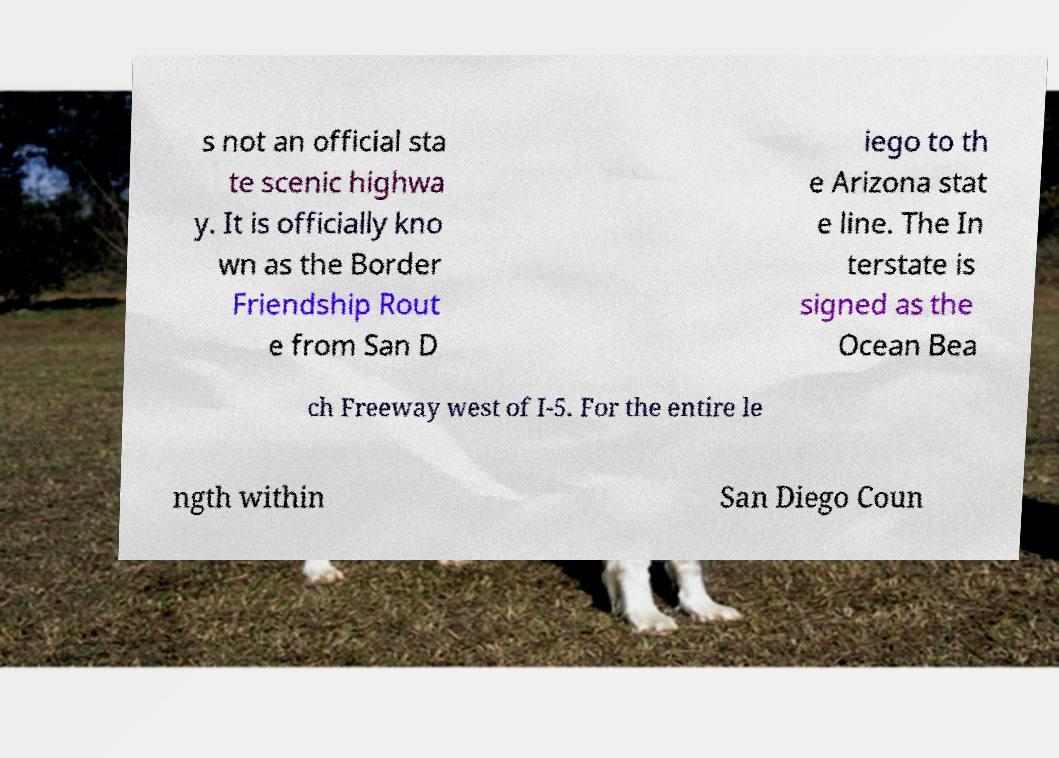Could you assist in decoding the text presented in this image and type it out clearly? s not an official sta te scenic highwa y. It is officially kno wn as the Border Friendship Rout e from San D iego to th e Arizona stat e line. The In terstate is signed as the Ocean Bea ch Freeway west of I-5. For the entire le ngth within San Diego Coun 